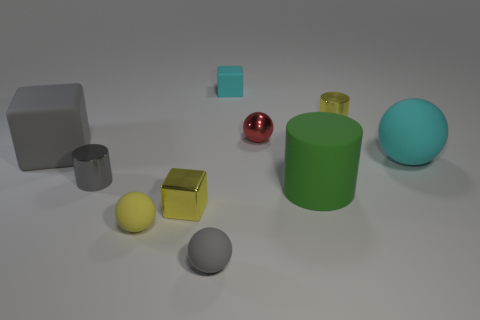Can you describe the color and finish of each object in the image? Certainly! In the image, we see a range of colors and finishes. Starting from the left, we have a gray matte block, a small blue matte cube, a shiny red sphere, a green matte cylinder, a large turquoise matte sphere, a yellow glossy cube, and a gray matte sphere. Each object's surface differs as well, with the red sphere and yellow cube having glossy finishes that reflect light, while the rest are matte and absorb light, providing no reflection. 